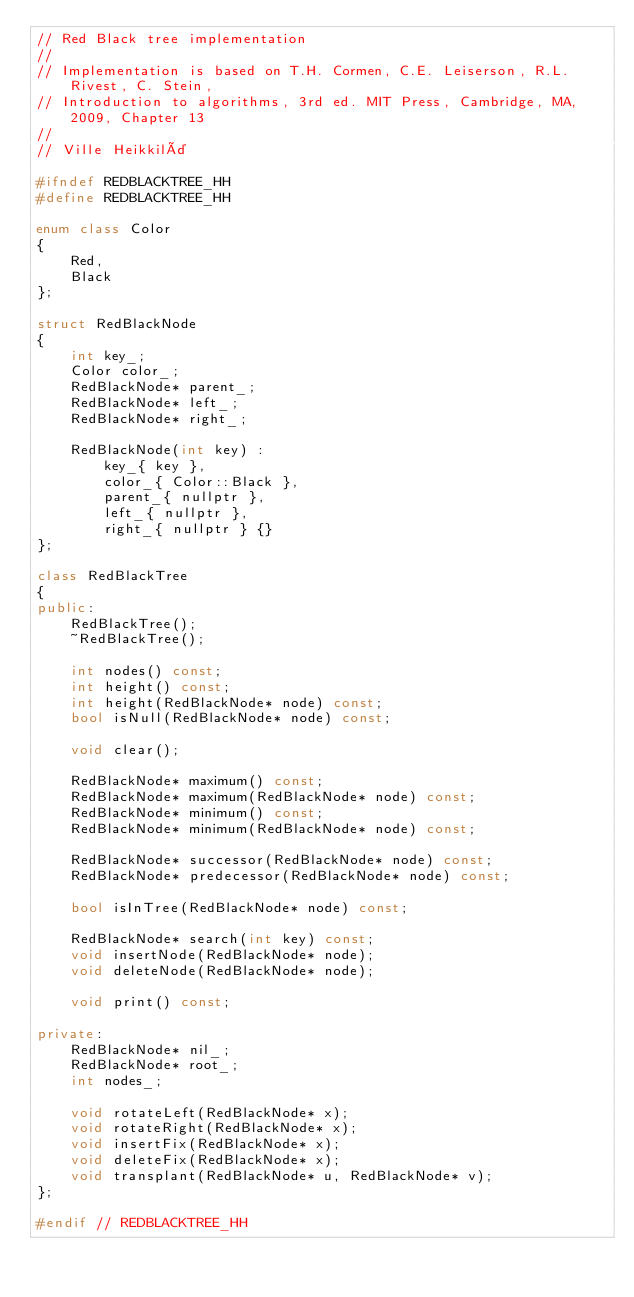<code> <loc_0><loc_0><loc_500><loc_500><_C++_>// Red Black tree implementation
//
// Implementation is based on T.H. Cormen, C.E. Leiserson, R.L. Rivest, C. Stein,
// Introduction to algorithms, 3rd ed. MIT Press, Cambridge, MA, 2009, Chapter 13
//
// Ville Heikkilä

#ifndef REDBLACKTREE_HH
#define REDBLACKTREE_HH

enum class Color
{
    Red,
    Black
};

struct RedBlackNode
{
    int key_;
    Color color_;
    RedBlackNode* parent_;
    RedBlackNode* left_;
    RedBlackNode* right_;

    RedBlackNode(int key) :
        key_{ key },
        color_{ Color::Black },
        parent_{ nullptr },
        left_{ nullptr },
        right_{ nullptr } {}
};

class RedBlackTree
{
public:
    RedBlackTree();
    ~RedBlackTree();

    int nodes() const;
    int height() const;
    int height(RedBlackNode* node) const;
    bool isNull(RedBlackNode* node) const;

    void clear();

    RedBlackNode* maximum() const;
    RedBlackNode* maximum(RedBlackNode* node) const;
    RedBlackNode* minimum() const;
    RedBlackNode* minimum(RedBlackNode* node) const;

    RedBlackNode* successor(RedBlackNode* node) const;
    RedBlackNode* predecessor(RedBlackNode* node) const;

    bool isInTree(RedBlackNode* node) const;

    RedBlackNode* search(int key) const;
    void insertNode(RedBlackNode* node);
    void deleteNode(RedBlackNode* node);

    void print() const;

private:
    RedBlackNode* nil_;
    RedBlackNode* root_;
    int nodes_;

    void rotateLeft(RedBlackNode* x);
    void rotateRight(RedBlackNode* x);
    void insertFix(RedBlackNode* x);
    void deleteFix(RedBlackNode* x);
    void transplant(RedBlackNode* u, RedBlackNode* v);
};

#endif // REDBLACKTREE_HH
</code> 